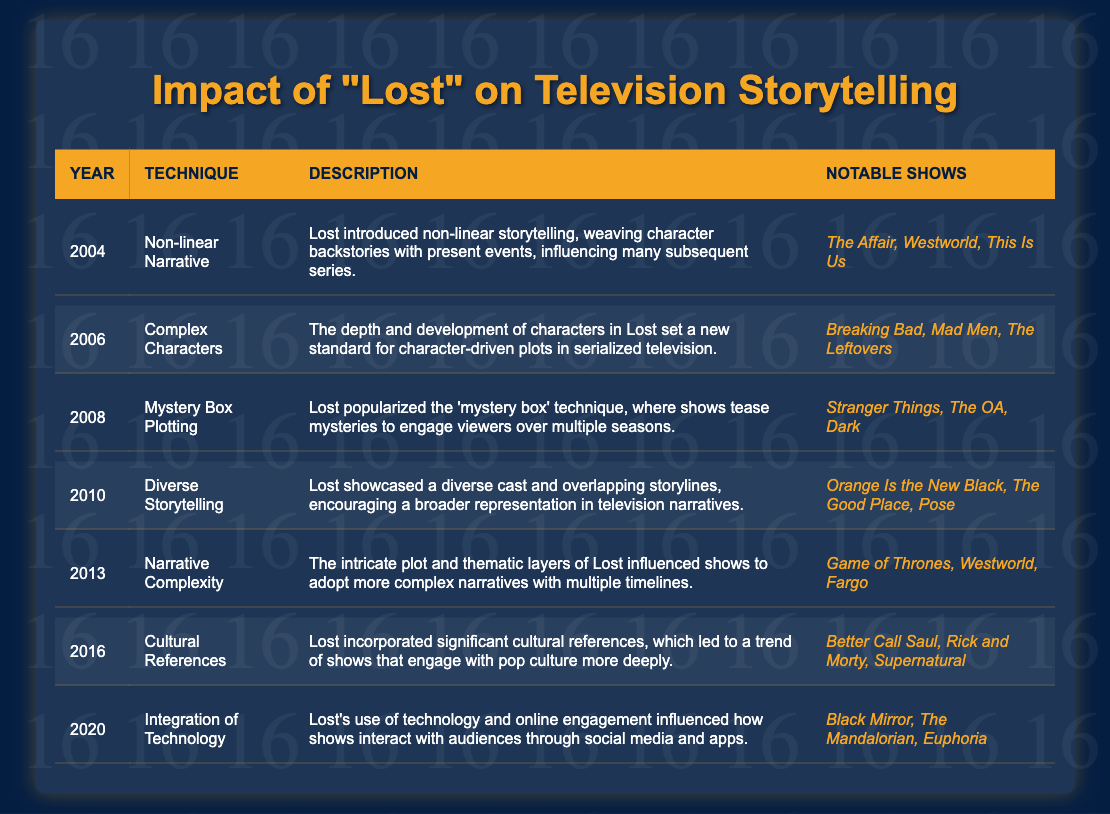What storytelling technique was introduced in 2004? According to the table, the technique introduced in 2004 is "Non-linear Narrative." This is found in the first row under the "Technique" column.
Answer: Non-linear Narrative Which year saw the introduction of "Complex Characters"? The table indicates that "Complex Characters" was introduced in 2006, as shown in the respective row.
Answer: 2006 Name one show that was influenced by the "Mystery Box Plotting" technique. The table lists several notable shows under the "Mystery Box Plotting" technique, including "Stranger Things."
Answer: Stranger Things Did "Lost" influence the use of cultural references in TV shows? Yes, the table states that "Lost" incorporated significant cultural references, which led to further engagement with pop culture in other shows, indicating a positive influence.
Answer: Yes How many years are listed in the table? The table contains entries from 2004 to 2020, totaling 7 years. This can be counted directly from the rows of the table.
Answer: 7 List all the notable shows related to the "Diverse Storytelling" technique. The table reveals that the notable shows for the "Diverse Storytelling" technique are "Orange Is the New Black," "The Good Place," and "Pose," so we can find them in the respective row.
Answer: Orange Is the New Black, The Good Place, Pose Which storytelling technique was introduced most recently, and in what year? The most recent technique introduced is "Integration of Technology," which was listed in the year 2020, evident from the last row of the table.
Answer: Integration of Technology, 2020 How many notable shows are listed for the "Narrative Complexity" technique? The table shows that the "Narrative Complexity" technique has three notable shows listed: "Game of Thrones," "Westworld," and "Fargo," thus counting them gives the answer.
Answer: 3 Which technique has influenced the most shows listed? "Complex Characters" and "Mystery Box Plotting" each have three notable shows listed under them: "Breaking Bad, Mad Men, The Leftovers" and "Stranger Things, The OA, Dark," respectively. Both techniques can be seen yielding the same quantity.
Answer: Complex Characters and Mystery Box Plotting From the years listed, which technique aligns with the highest degree of narrative complexity? The table indicates that "Narrative Complexity," introduced in 2013, is directly related to intricate plots and multiple timelines, making it the most complex technique listed, as it encompasses greater narrative elements.
Answer: Narrative Complexity What is the relationship between "Diverse Storytelling" and the representation of characters in other shows? The table indicates that "Diverse Storytelling" set a trend for broader representation in television narratives. This implies that other shows likely followed this pattern after observing "Lost's" approach.
Answer: Broader representation in narratives 